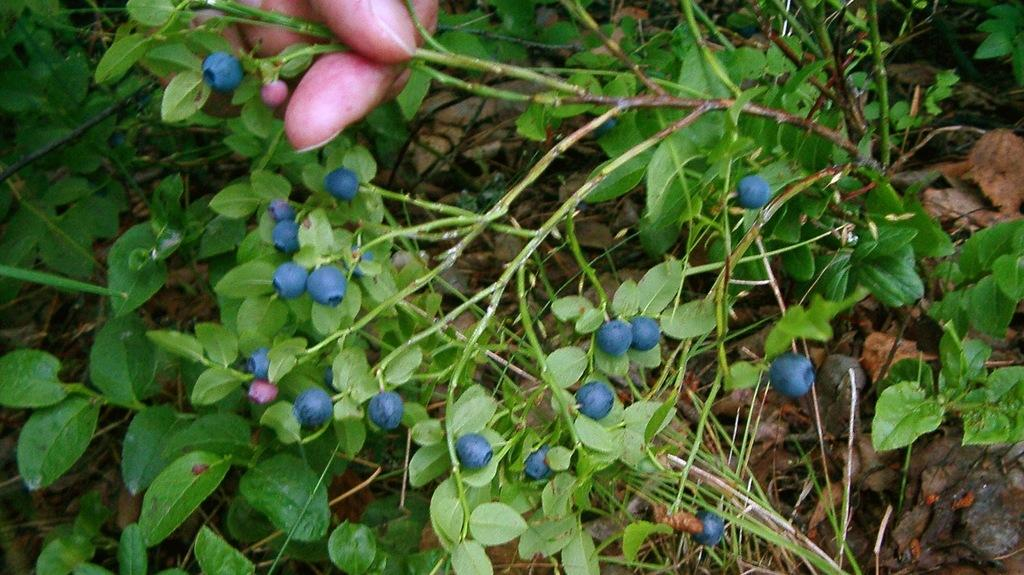What can be seen in the image related to a person's hand? There is a person's hand in the image, and it is holding the stem of a plant. What is the plant holding by the person's hand? The plant has berries on it. Are there any other plants visible in the image? Yes, there are other plants visible in the image. What type of crime is being committed in the image? There is no indication of any crime being committed in the image; it features a person's hand holding a plant with berries. What time of day is depicted in the image? The provided facts do not give any information about the time of day depicted in the image. 